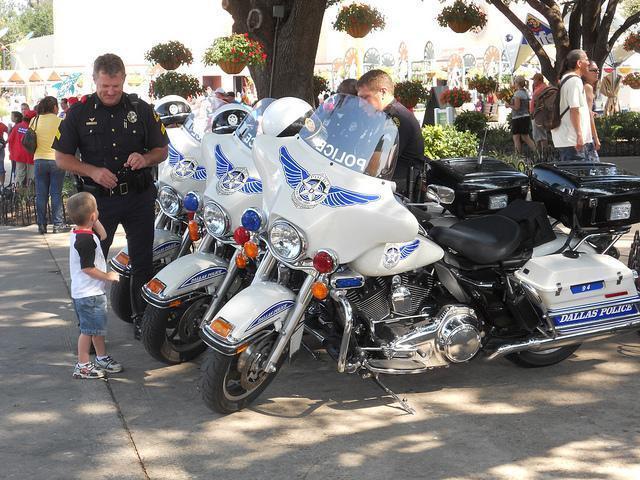How many motorcycles are visible?
Give a very brief answer. 3. How many people are there?
Give a very brief answer. 5. 